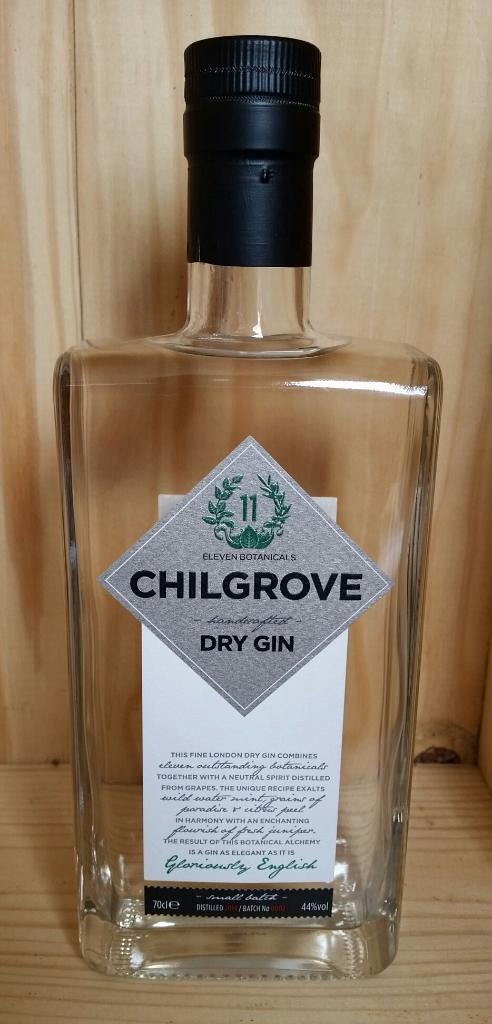<image>
Write a terse but informative summary of the picture. a bottle of chillgrove dry gin, still closed and full, 